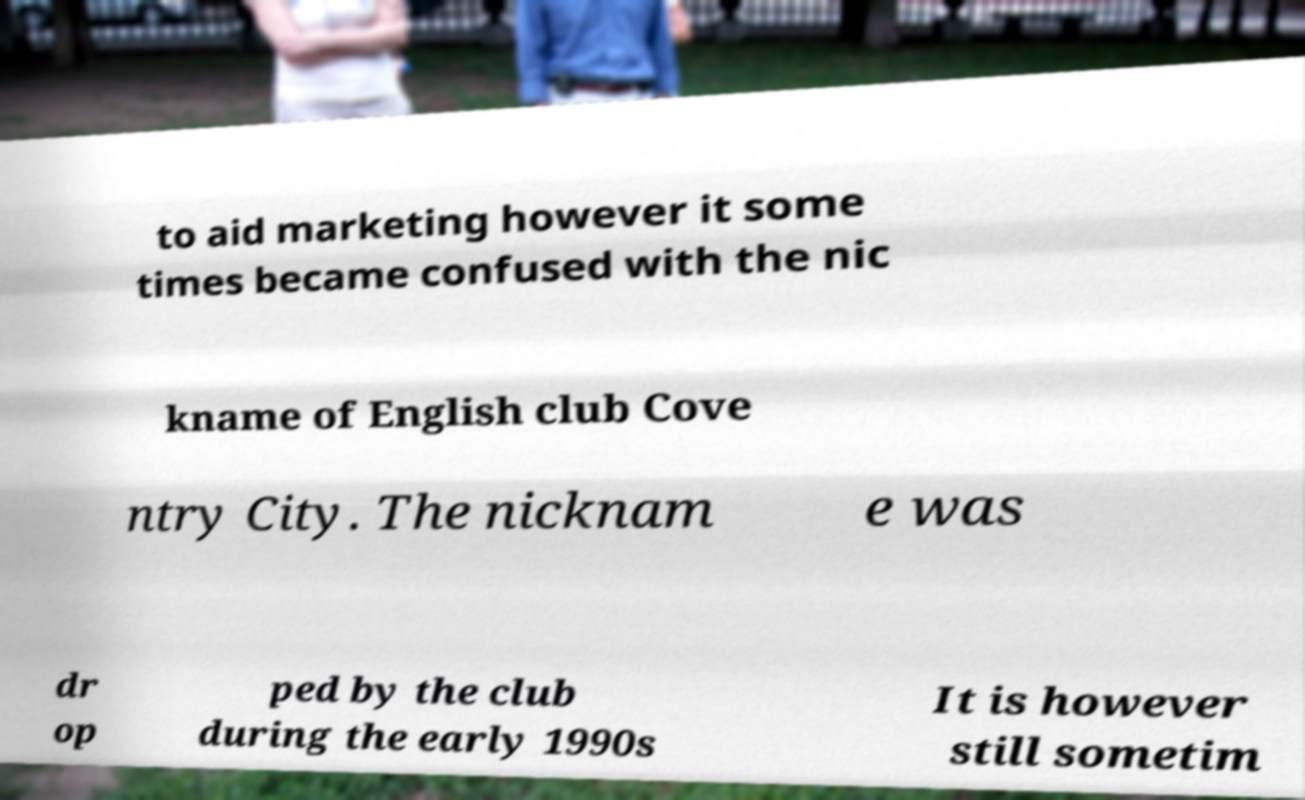I need the written content from this picture converted into text. Can you do that? to aid marketing however it some times became confused with the nic kname of English club Cove ntry City. The nicknam e was dr op ped by the club during the early 1990s It is however still sometim 